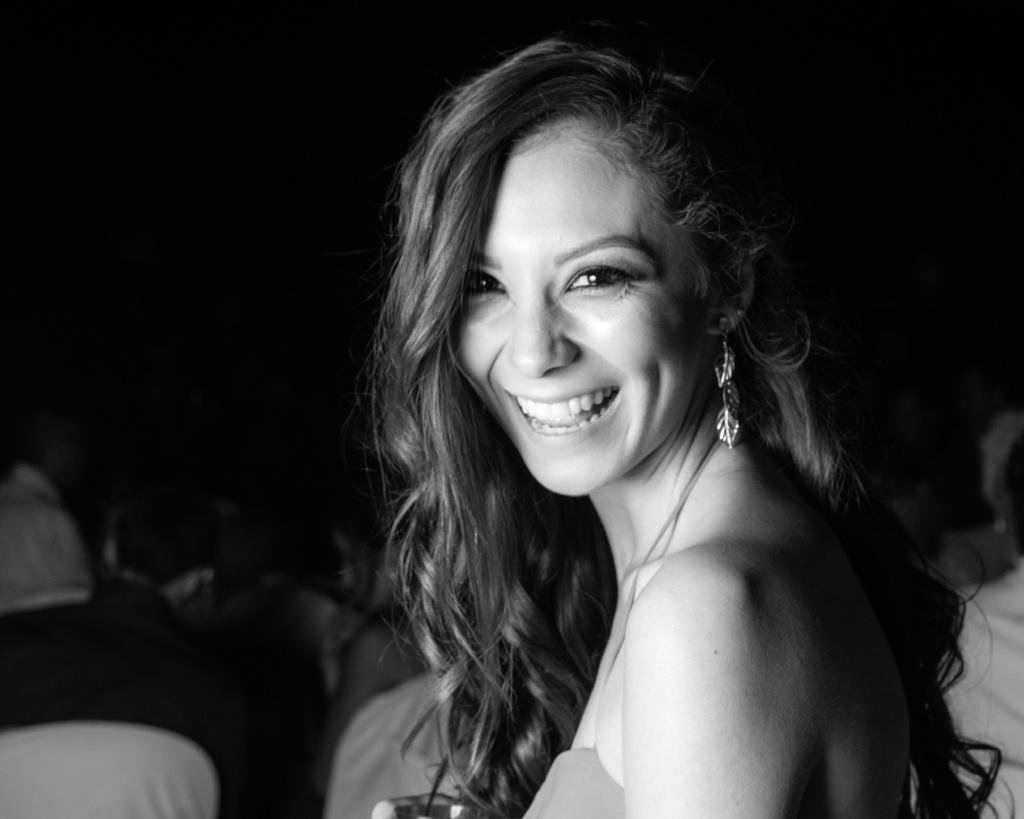What is the color scheme of the image? The image is black and white. Who is present in the image? There is a woman in the image. What is the woman's facial expression? The woman is smiling. What can be seen in the background of the image? The background of the woman is dark. What type of jewelry is the woman wearing? The woman is wearing leaf design earrings. What key discovery did the woman make in the image? There is no indication of a key discovery in the image; it simply shows a woman smiling with a dark background and leaf design earrings. 